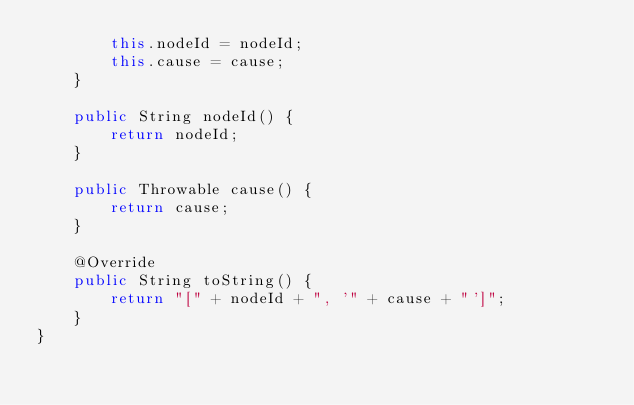<code> <loc_0><loc_0><loc_500><loc_500><_Java_>        this.nodeId = nodeId;
        this.cause = cause;
    }

    public String nodeId() {
        return nodeId;
    }

    public Throwable cause() {
        return cause;
    }

    @Override
    public String toString() {
        return "[" + nodeId + ", '" + cause + "']";
    }
}
</code> 